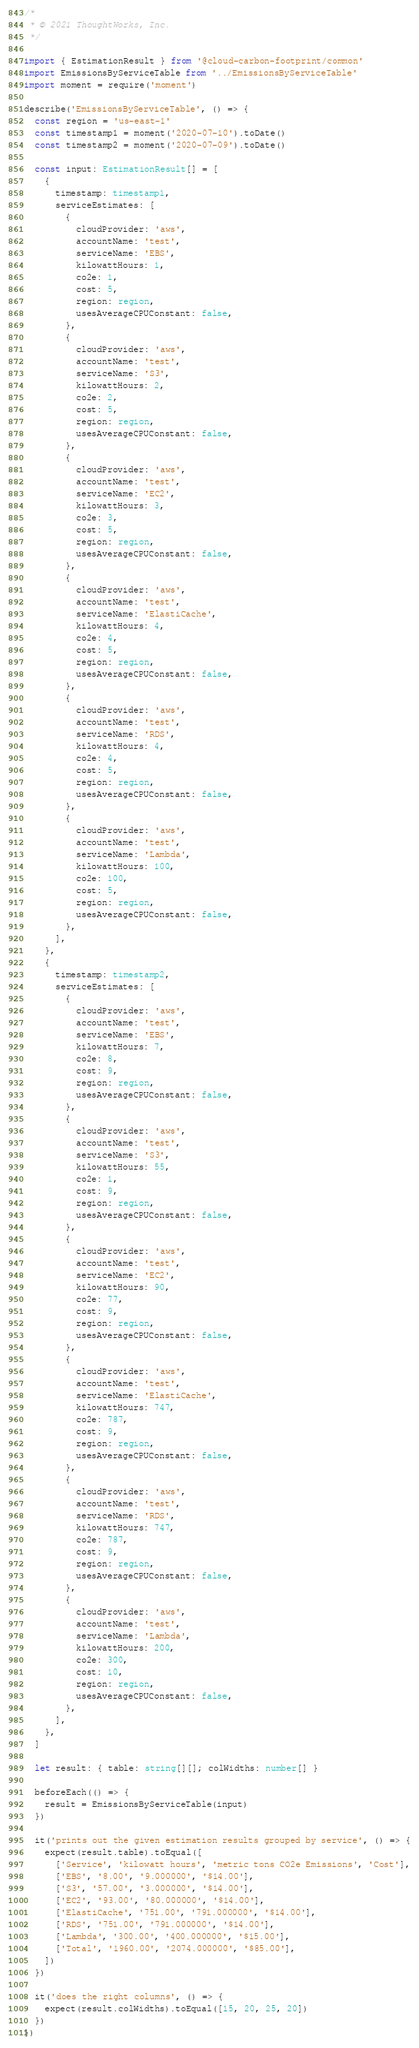Convert code to text. <code><loc_0><loc_0><loc_500><loc_500><_TypeScript_>/*
 * © 2021 ThoughtWorks, Inc.
 */

import { EstimationResult } from '@cloud-carbon-footprint/common'
import EmissionsByServiceTable from '../EmissionsByServiceTable'
import moment = require('moment')

describe('EmissionsByServiceTable', () => {
  const region = 'us-east-1'
  const timestamp1 = moment('2020-07-10').toDate()
  const timestamp2 = moment('2020-07-09').toDate()

  const input: EstimationResult[] = [
    {
      timestamp: timestamp1,
      serviceEstimates: [
        {
          cloudProvider: 'aws',
          accountName: 'test',
          serviceName: 'EBS',
          kilowattHours: 1,
          co2e: 1,
          cost: 5,
          region: region,
          usesAverageCPUConstant: false,
        },
        {
          cloudProvider: 'aws',
          accountName: 'test',
          serviceName: 'S3',
          kilowattHours: 2,
          co2e: 2,
          cost: 5,
          region: region,
          usesAverageCPUConstant: false,
        },
        {
          cloudProvider: 'aws',
          accountName: 'test',
          serviceName: 'EC2',
          kilowattHours: 3,
          co2e: 3,
          cost: 5,
          region: region,
          usesAverageCPUConstant: false,
        },
        {
          cloudProvider: 'aws',
          accountName: 'test',
          serviceName: 'ElastiCache',
          kilowattHours: 4,
          co2e: 4,
          cost: 5,
          region: region,
          usesAverageCPUConstant: false,
        },
        {
          cloudProvider: 'aws',
          accountName: 'test',
          serviceName: 'RDS',
          kilowattHours: 4,
          co2e: 4,
          cost: 5,
          region: region,
          usesAverageCPUConstant: false,
        },
        {
          cloudProvider: 'aws',
          accountName: 'test',
          serviceName: 'Lambda',
          kilowattHours: 100,
          co2e: 100,
          cost: 5,
          region: region,
          usesAverageCPUConstant: false,
        },
      ],
    },
    {
      timestamp: timestamp2,
      serviceEstimates: [
        {
          cloudProvider: 'aws',
          accountName: 'test',
          serviceName: 'EBS',
          kilowattHours: 7,
          co2e: 8,
          cost: 9,
          region: region,
          usesAverageCPUConstant: false,
        },
        {
          cloudProvider: 'aws',
          accountName: 'test',
          serviceName: 'S3',
          kilowattHours: 55,
          co2e: 1,
          cost: 9,
          region: region,
          usesAverageCPUConstant: false,
        },
        {
          cloudProvider: 'aws',
          accountName: 'test',
          serviceName: 'EC2',
          kilowattHours: 90,
          co2e: 77,
          cost: 9,
          region: region,
          usesAverageCPUConstant: false,
        },
        {
          cloudProvider: 'aws',
          accountName: 'test',
          serviceName: 'ElastiCache',
          kilowattHours: 747,
          co2e: 787,
          cost: 9,
          region: region,
          usesAverageCPUConstant: false,
        },
        {
          cloudProvider: 'aws',
          accountName: 'test',
          serviceName: 'RDS',
          kilowattHours: 747,
          co2e: 787,
          cost: 9,
          region: region,
          usesAverageCPUConstant: false,
        },
        {
          cloudProvider: 'aws',
          accountName: 'test',
          serviceName: 'Lambda',
          kilowattHours: 200,
          co2e: 300,
          cost: 10,
          region: region,
          usesAverageCPUConstant: false,
        },
      ],
    },
  ]

  let result: { table: string[][]; colWidths: number[] }

  beforeEach(() => {
    result = EmissionsByServiceTable(input)
  })

  it('prints out the given estimation results grouped by service', () => {
    expect(result.table).toEqual([
      ['Service', 'kilowatt hours', 'metric tons CO2e Emissions', 'Cost'],
      ['EBS', '8.00', '9.000000', '$14.00'],
      ['S3', '57.00', '3.000000', '$14.00'],
      ['EC2', '93.00', '80.000000', '$14.00'],
      ['ElastiCache', '751.00', '791.000000', '$14.00'],
      ['RDS', '751.00', '791.000000', '$14.00'],
      ['Lambda', '300.00', '400.000000', '$15.00'],
      ['Total', '1960.00', '2074.000000', '$85.00'],
    ])
  })

  it('does the right columns', () => {
    expect(result.colWidths).toEqual([15, 20, 25, 20])
  })
})
</code> 